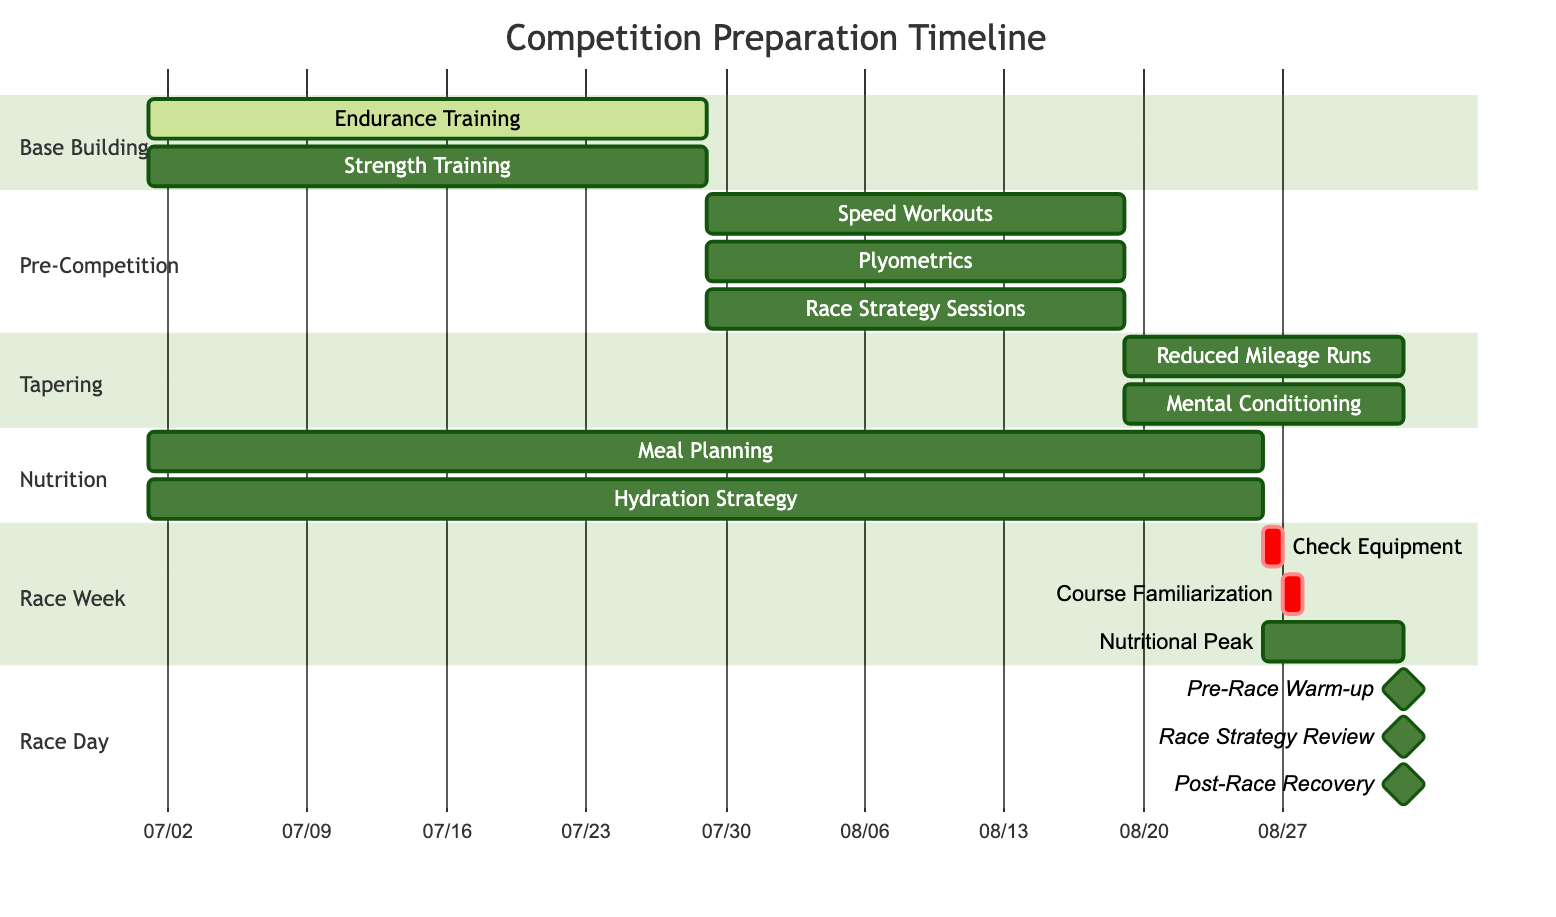How long is the Base Building phase? The Base Building phase has a specified duration of 4 weeks. This information is indicated clearly in the timeline.
Answer: 4 weeks How many activities are there in the Pre-Competition phase? The Pre-Competition phase includes three distinct activities: Speed Workouts, Plyometrics, and Race Strategy Sessions. Thus, the total is three activities.
Answer: 3 What is the frequency of Mental Conditioning during the Tapering phase? In the Tapering phase, Mental Conditioning is to be performed daily as indicated in the activities outlined.
Answer: Daily What activity overlaps between the Base Building and Nutrition sections? The activity that overlaps is Meal Planning, as it is present during the same timeframe of 8 weeks starting from July 1st.
Answer: Meal Planning Which two phases have activities scheduled to start on July 29th? The phases that start activities on July 29th are Pre-Competition (Speed Workouts, Plyometrics, Race Strategy Sessions) and Tapering (Reduced Mileage Runs, Mental Conditioning).
Answer: Pre-Competition and Tapering How many days are allocated for Race Week? The Race Week is allocated a duration of 7 days, with activities spread throughout that week.
Answer: 7 days What is the total duration of the Competition Preparation Timeline? The total duration is 10 weeks, starting from July 1st and concluding on the day of the race, September 2nd, which spans from that date inclusive.
Answer: 10 weeks What is the last activity listed in the Race Day section? The last activity listed in the Race Day section is Post-Race Recovery, which is scheduled for immediate post-race.
Answer: Post-Race Recovery What type of training is specifically mentioned to occur twice a week during the Base Building? The type of training specified to occur twice a week during the Base Building phase is Strength Training, focusing on lower body and core strength.
Answer: Strength Training 